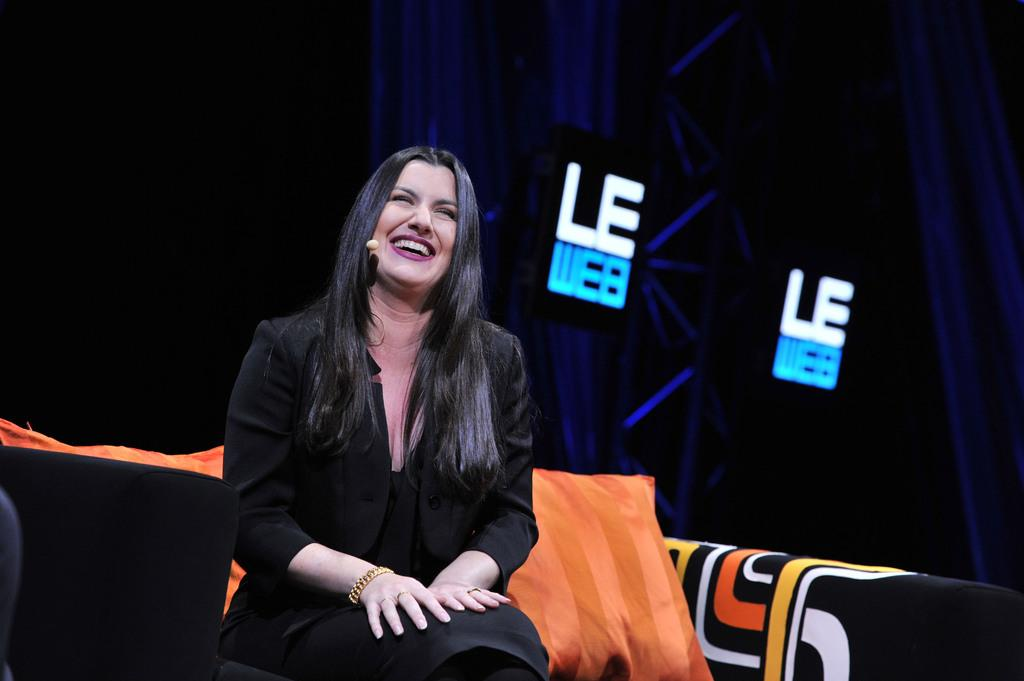Who is the main subject in the image? There is a woman in the image. Where is the woman located in the image? The woman is in the middle of the image. What expression does the woman have? The woman is smiling. What else can be seen in the image besides the woman? There is text with lights in the image. What type of haircut does the woman's mother have in the image? There is no mention of the woman's mother in the image, so we cannot determine her haircut. 